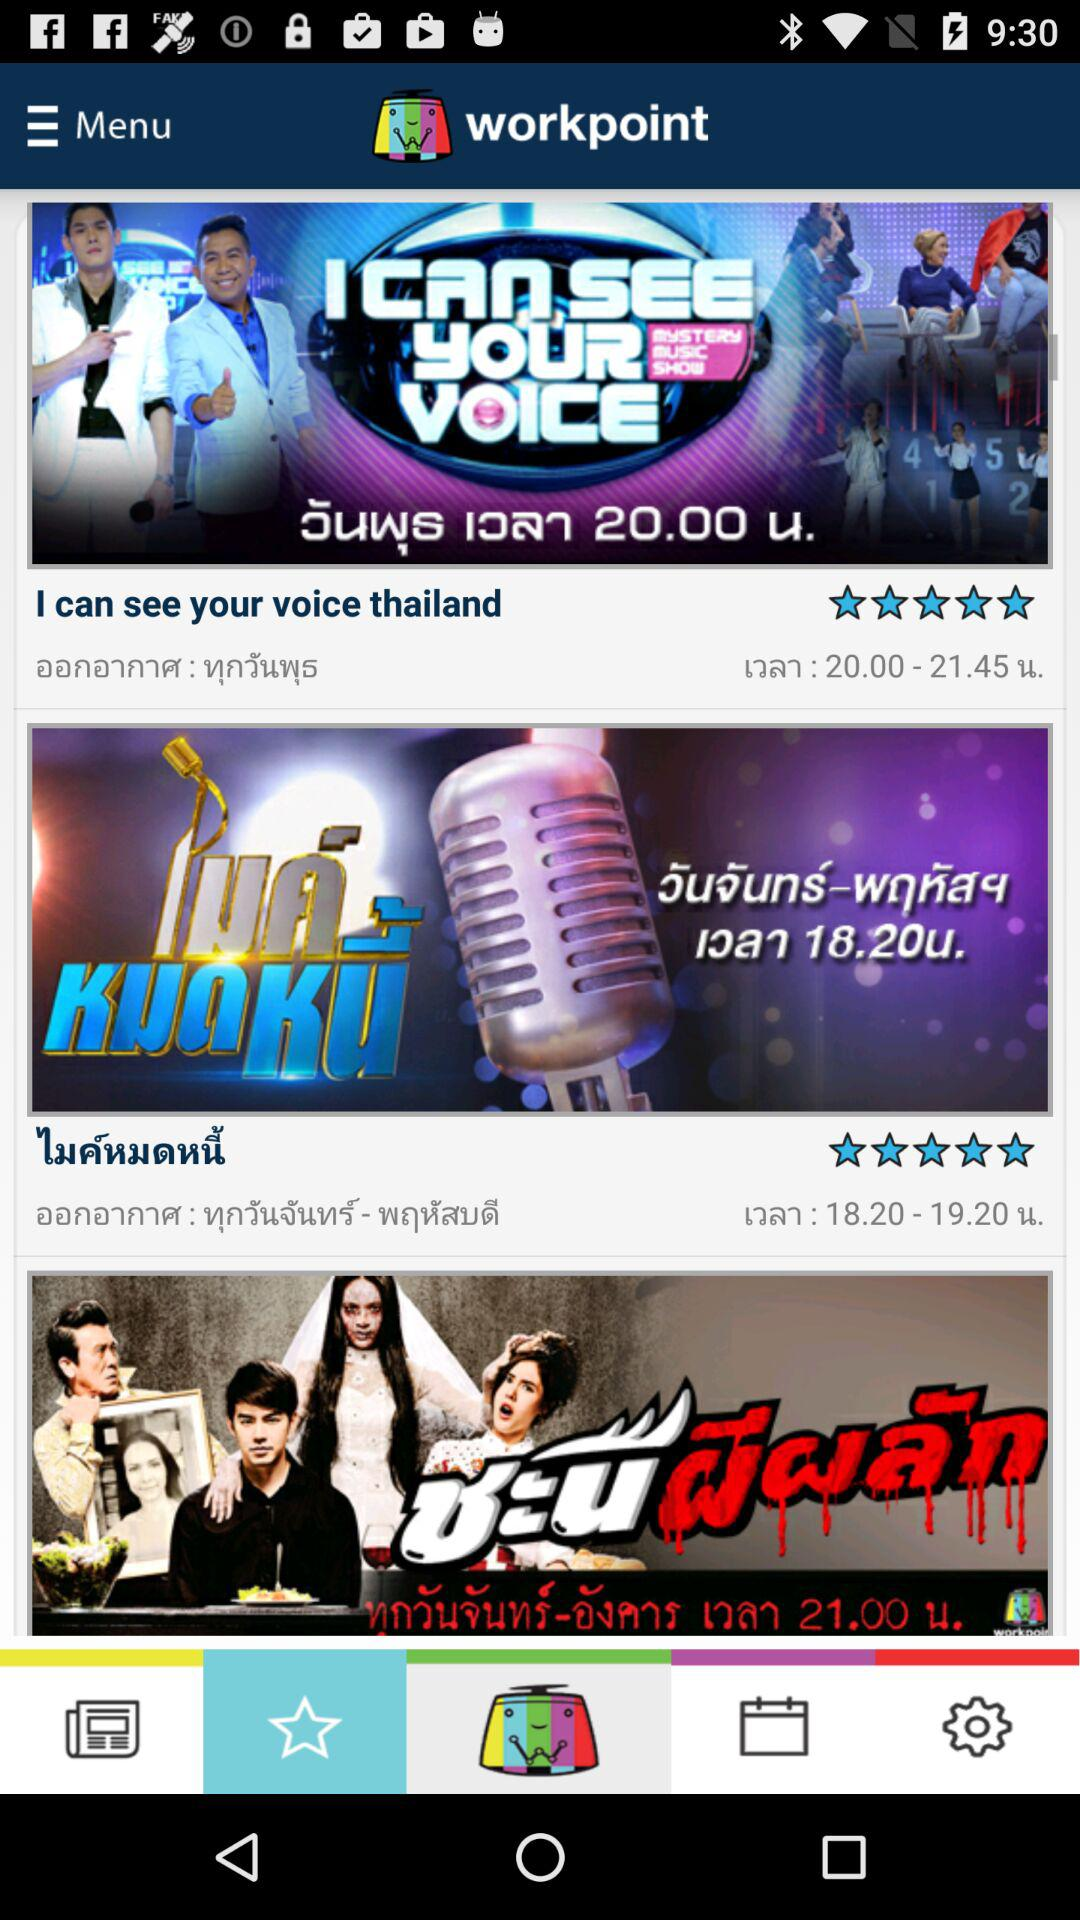What is the selected tab? The selected tab is "Favorites". 